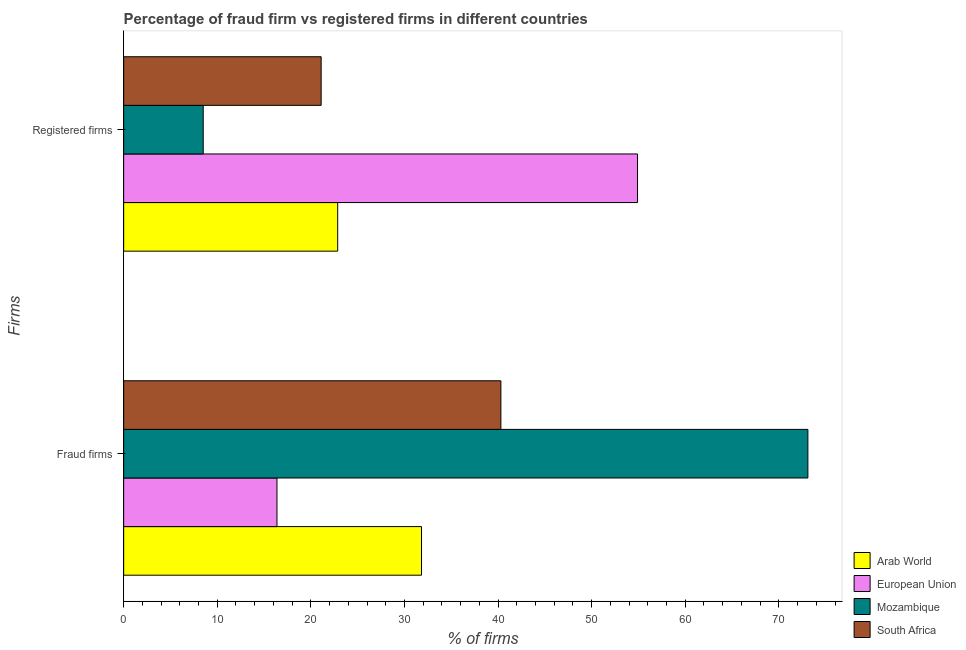How many groups of bars are there?
Make the answer very short. 2. Are the number of bars per tick equal to the number of legend labels?
Offer a terse response. Yes. Are the number of bars on each tick of the Y-axis equal?
Ensure brevity in your answer.  Yes. How many bars are there on the 2nd tick from the top?
Provide a short and direct response. 4. What is the label of the 1st group of bars from the top?
Make the answer very short. Registered firms. What is the percentage of registered firms in South Africa?
Your response must be concise. 21.1. Across all countries, what is the maximum percentage of registered firms?
Offer a terse response. 54.9. Across all countries, what is the minimum percentage of registered firms?
Offer a very short reply. 8.5. What is the total percentage of registered firms in the graph?
Make the answer very short. 107.37. What is the difference between the percentage of fraud firms in Arab World and that in South Africa?
Make the answer very short. -8.48. What is the difference between the percentage of fraud firms in South Africa and the percentage of registered firms in Arab World?
Make the answer very short. 17.43. What is the average percentage of registered firms per country?
Provide a succinct answer. 26.84. What is the difference between the percentage of registered firms and percentage of fraud firms in Arab World?
Your answer should be compact. -8.95. In how many countries, is the percentage of fraud firms greater than 70 %?
Your answer should be compact. 1. What is the ratio of the percentage of fraud firms in Arab World to that in South Africa?
Ensure brevity in your answer.  0.79. What does the 4th bar from the top in Fraud firms represents?
Ensure brevity in your answer.  Arab World. Are all the bars in the graph horizontal?
Provide a short and direct response. Yes. Does the graph contain any zero values?
Offer a very short reply. No. Does the graph contain grids?
Keep it short and to the point. No. What is the title of the graph?
Make the answer very short. Percentage of fraud firm vs registered firms in different countries. What is the label or title of the X-axis?
Keep it short and to the point. % of firms. What is the label or title of the Y-axis?
Offer a terse response. Firms. What is the % of firms in Arab World in Fraud firms?
Provide a short and direct response. 31.82. What is the % of firms in European Union in Fraud firms?
Your response must be concise. 16.38. What is the % of firms in Mozambique in Fraud firms?
Keep it short and to the point. 73.1. What is the % of firms of South Africa in Fraud firms?
Ensure brevity in your answer.  40.3. What is the % of firms of Arab World in Registered firms?
Your response must be concise. 22.87. What is the % of firms in European Union in Registered firms?
Your answer should be compact. 54.9. What is the % of firms in South Africa in Registered firms?
Your answer should be very brief. 21.1. Across all Firms, what is the maximum % of firms of Arab World?
Ensure brevity in your answer.  31.82. Across all Firms, what is the maximum % of firms in European Union?
Your answer should be compact. 54.9. Across all Firms, what is the maximum % of firms of Mozambique?
Offer a terse response. 73.1. Across all Firms, what is the maximum % of firms of South Africa?
Offer a terse response. 40.3. Across all Firms, what is the minimum % of firms in Arab World?
Keep it short and to the point. 22.87. Across all Firms, what is the minimum % of firms of European Union?
Your answer should be very brief. 16.38. Across all Firms, what is the minimum % of firms of Mozambique?
Ensure brevity in your answer.  8.5. Across all Firms, what is the minimum % of firms in South Africa?
Give a very brief answer. 21.1. What is the total % of firms in Arab World in the graph?
Offer a very short reply. 54.69. What is the total % of firms of European Union in the graph?
Ensure brevity in your answer.  71.28. What is the total % of firms of Mozambique in the graph?
Give a very brief answer. 81.6. What is the total % of firms of South Africa in the graph?
Provide a short and direct response. 61.4. What is the difference between the % of firms of Arab World in Fraud firms and that in Registered firms?
Your answer should be compact. 8.95. What is the difference between the % of firms in European Union in Fraud firms and that in Registered firms?
Your response must be concise. -38.52. What is the difference between the % of firms in Mozambique in Fraud firms and that in Registered firms?
Give a very brief answer. 64.6. What is the difference between the % of firms of Arab World in Fraud firms and the % of firms of European Union in Registered firms?
Offer a very short reply. -23.08. What is the difference between the % of firms in Arab World in Fraud firms and the % of firms in Mozambique in Registered firms?
Offer a very short reply. 23.32. What is the difference between the % of firms of Arab World in Fraud firms and the % of firms of South Africa in Registered firms?
Your answer should be compact. 10.72. What is the difference between the % of firms in European Union in Fraud firms and the % of firms in Mozambique in Registered firms?
Make the answer very short. 7.88. What is the difference between the % of firms in European Union in Fraud firms and the % of firms in South Africa in Registered firms?
Provide a short and direct response. -4.72. What is the difference between the % of firms of Mozambique in Fraud firms and the % of firms of South Africa in Registered firms?
Provide a succinct answer. 52. What is the average % of firms in Arab World per Firms?
Provide a short and direct response. 27.34. What is the average % of firms in European Union per Firms?
Your response must be concise. 35.64. What is the average % of firms of Mozambique per Firms?
Ensure brevity in your answer.  40.8. What is the average % of firms of South Africa per Firms?
Provide a short and direct response. 30.7. What is the difference between the % of firms in Arab World and % of firms in European Union in Fraud firms?
Keep it short and to the point. 15.44. What is the difference between the % of firms of Arab World and % of firms of Mozambique in Fraud firms?
Offer a very short reply. -41.28. What is the difference between the % of firms of Arab World and % of firms of South Africa in Fraud firms?
Make the answer very short. -8.48. What is the difference between the % of firms of European Union and % of firms of Mozambique in Fraud firms?
Make the answer very short. -56.72. What is the difference between the % of firms of European Union and % of firms of South Africa in Fraud firms?
Offer a terse response. -23.92. What is the difference between the % of firms in Mozambique and % of firms in South Africa in Fraud firms?
Give a very brief answer. 32.8. What is the difference between the % of firms of Arab World and % of firms of European Union in Registered firms?
Give a very brief answer. -32.03. What is the difference between the % of firms in Arab World and % of firms in Mozambique in Registered firms?
Offer a very short reply. 14.37. What is the difference between the % of firms in Arab World and % of firms in South Africa in Registered firms?
Your answer should be compact. 1.77. What is the difference between the % of firms of European Union and % of firms of Mozambique in Registered firms?
Offer a terse response. 46.4. What is the difference between the % of firms in European Union and % of firms in South Africa in Registered firms?
Give a very brief answer. 33.8. What is the ratio of the % of firms of Arab World in Fraud firms to that in Registered firms?
Provide a succinct answer. 1.39. What is the ratio of the % of firms of European Union in Fraud firms to that in Registered firms?
Your answer should be very brief. 0.3. What is the ratio of the % of firms of South Africa in Fraud firms to that in Registered firms?
Offer a very short reply. 1.91. What is the difference between the highest and the second highest % of firms in Arab World?
Offer a very short reply. 8.95. What is the difference between the highest and the second highest % of firms of European Union?
Your answer should be compact. 38.52. What is the difference between the highest and the second highest % of firms in Mozambique?
Provide a short and direct response. 64.6. What is the difference between the highest and the second highest % of firms of South Africa?
Provide a short and direct response. 19.2. What is the difference between the highest and the lowest % of firms in Arab World?
Your answer should be compact. 8.95. What is the difference between the highest and the lowest % of firms of European Union?
Keep it short and to the point. 38.52. What is the difference between the highest and the lowest % of firms of Mozambique?
Provide a succinct answer. 64.6. 